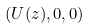<formula> <loc_0><loc_0><loc_500><loc_500>( U ( z ) , 0 , 0 )</formula> 